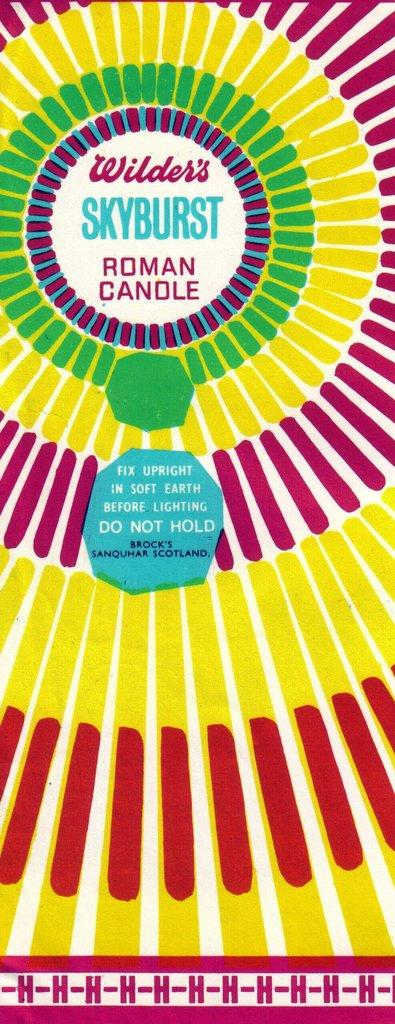<image>
Offer a succinct explanation of the picture presented. A colorful label for a Skyburst Roman candle composed of circles made of lines. 